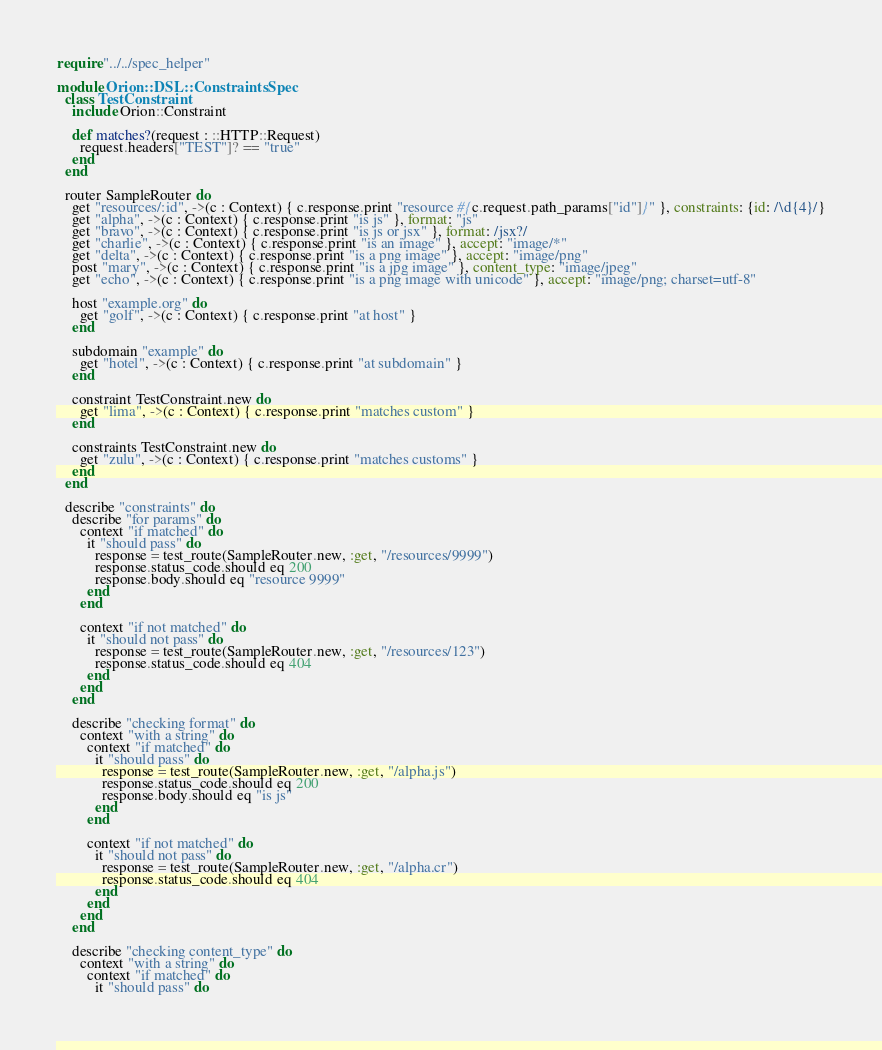Convert code to text. <code><loc_0><loc_0><loc_500><loc_500><_Crystal_>require "../../spec_helper"

module Orion::DSL::ConstraintsSpec
  class TestConstraint
    include Orion::Constraint

    def matches?(request : ::HTTP::Request)
      request.headers["TEST"]? == "true"
    end
  end

  router SampleRouter do
    get "resources/:id", ->(c : Context) { c.response.print "resource #{c.request.path_params["id"]}" }, constraints: {id: /\d{4}/}
    get "alpha", ->(c : Context) { c.response.print "is js" }, format: "js"
    get "bravo", ->(c : Context) { c.response.print "is js or jsx" }, format: /jsx?/
    get "charlie", ->(c : Context) { c.response.print "is an image" }, accept: "image/*"
    get "delta", ->(c : Context) { c.response.print "is a png image" }, accept: "image/png"
    post "mary", ->(c : Context) { c.response.print "is a jpg image" }, content_type: "image/jpeg"
    get "echo", ->(c : Context) { c.response.print "is a png image with unicode" }, accept: "image/png; charset=utf-8"

    host "example.org" do
      get "golf", ->(c : Context) { c.response.print "at host" }
    end

    subdomain "example" do
      get "hotel", ->(c : Context) { c.response.print "at subdomain" }
    end

    constraint TestConstraint.new do
      get "lima", ->(c : Context) { c.response.print "matches custom" }
    end

    constraints TestConstraint.new do
      get "zulu", ->(c : Context) { c.response.print "matches customs" }
    end
  end

  describe "constraints" do
    describe "for params" do
      context "if matched" do
        it "should pass" do
          response = test_route(SampleRouter.new, :get, "/resources/9999")
          response.status_code.should eq 200
          response.body.should eq "resource 9999"
        end
      end

      context "if not matched" do
        it "should not pass" do
          response = test_route(SampleRouter.new, :get, "/resources/123")
          response.status_code.should eq 404
        end
      end
    end

    describe "checking format" do
      context "with a string" do
        context "if matched" do
          it "should pass" do
            response = test_route(SampleRouter.new, :get, "/alpha.js")
            response.status_code.should eq 200
            response.body.should eq "is js"
          end
        end

        context "if not matched" do
          it "should not pass" do
            response = test_route(SampleRouter.new, :get, "/alpha.cr")
            response.status_code.should eq 404
          end
        end
      end
    end

    describe "checking content_type" do
      context "with a string" do
        context "if matched" do
          it "should pass" do</code> 